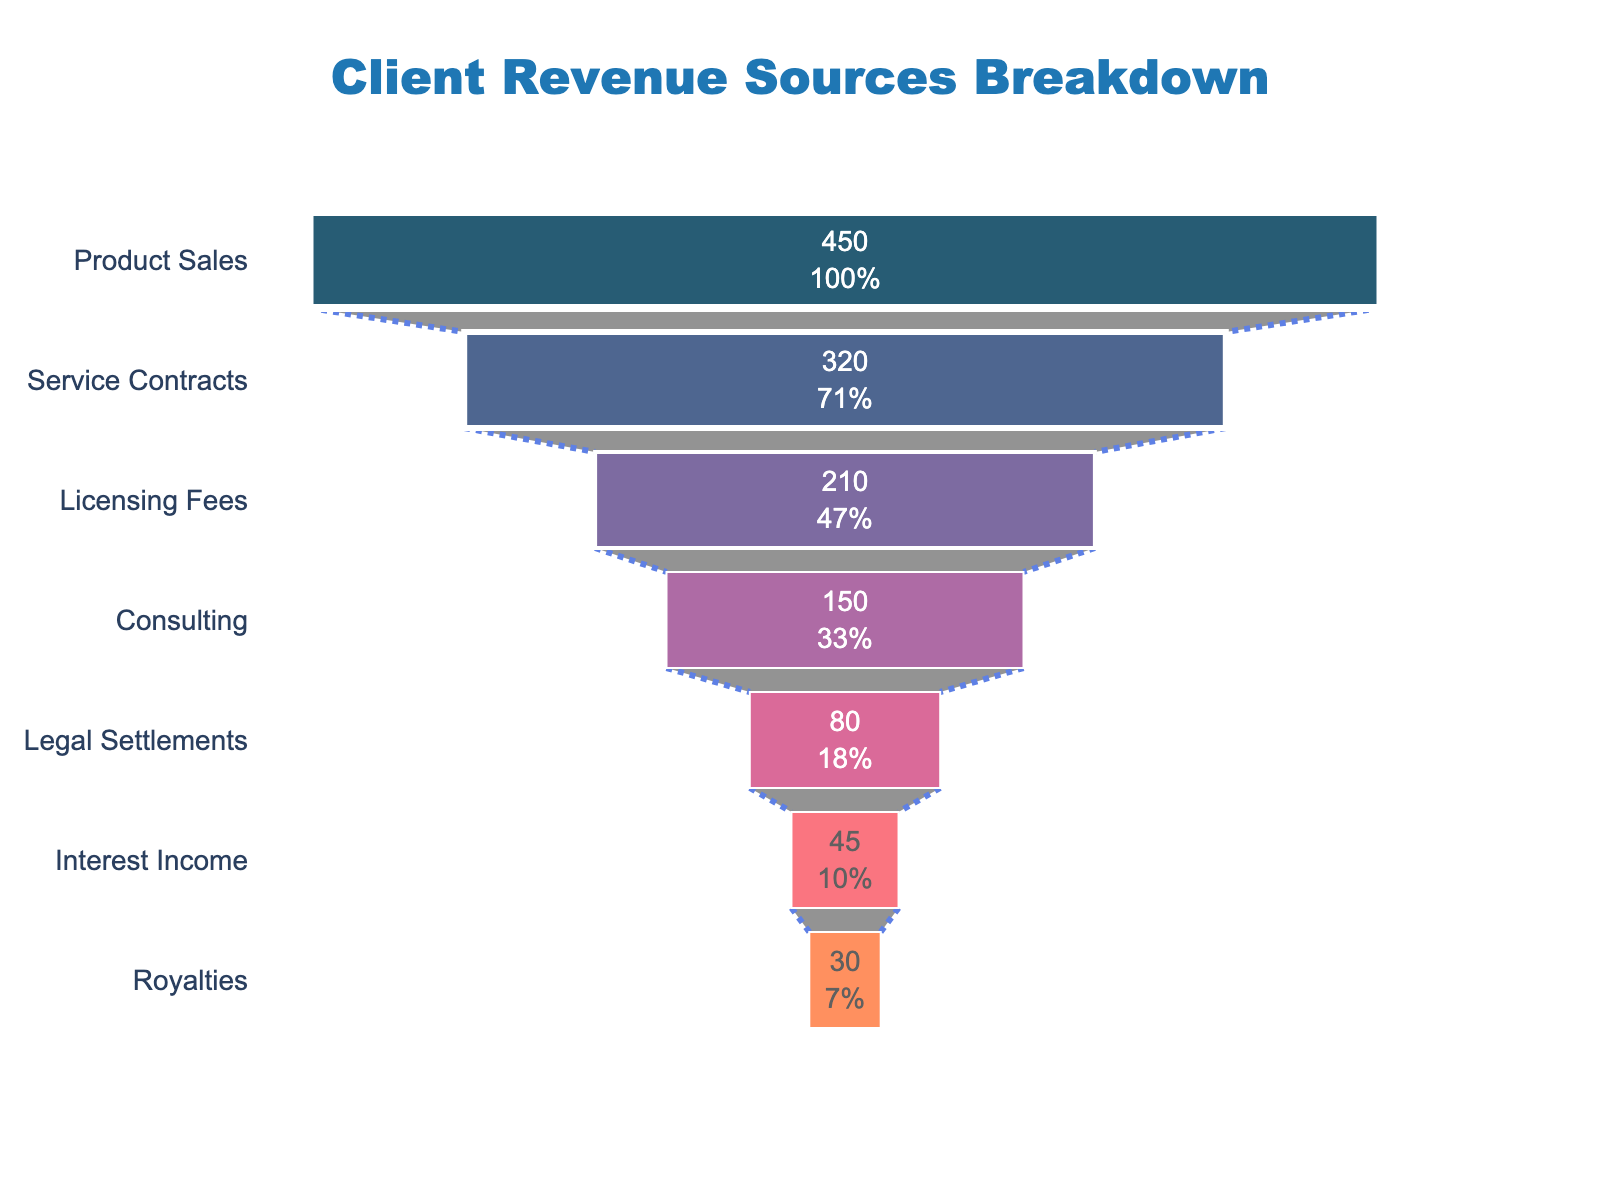What is the title of the funnel chart? The title is prominently displayed at the top center of the figure.
Answer: Client Revenue Sources Breakdown How many revenue stages are listed in the funnel chart? By counting the individual stages listed on the left side of the funnel, we see seven different stages.
Answer: Seven Which revenue source contributes the highest amount? The funnel section at the top represents the largest revenue contribution. The label says "Product Sales".
Answer: Product Sales What is the sum of the revenue from Licensing Fees and Service Contracts? Referred to the revenue amounts listed for both stages. Licensing Fees: $210M, Service Contracts: $320M. Adding these gives 210 + 320.
Answer: $530M How does Interest Income compare to Legal Settlements in terms of revenue? Compare the amounts directly from the figure. Interest Income: $45M, Legal Settlements: $80M.
Answer: Interest Income is less than Legal Settlements What's the average revenue amount of all the stages? Sum all revenue amounts: 450 + 320 + 210 + 150 + 80 + 45 + 30 = 1285. Divide by the number of stages, which is seven. So, 1285/7.
Answer: $183.57M Which three stages contribute the least revenue together, and what is their total contribution? Identify the three stages with the lowest revenue: Royalties: $30M, Interest Income: $45M, Legal Settlements: $80M. Sum these values. 30 + 45 + 80.
Answer: $155M What portion of the total revenue does Product Sales constitute? First, calculate the total revenue: 450 + 320 + 210 + 150 + 80 + 45 + 30 = 1285. Product Sales revenue is $450M. To find the portion, divide 450 by 1285 and convert to percentage. (450 / 1285) * 100 ≈ 35%
Answer: 35% Which stage has the second-largest revenue and how much is it? After Product Sales, the next largest section in the funnel represents Service Contracts. The revenue is indicated as $320M.
Answer: Service Contracts, $320M 